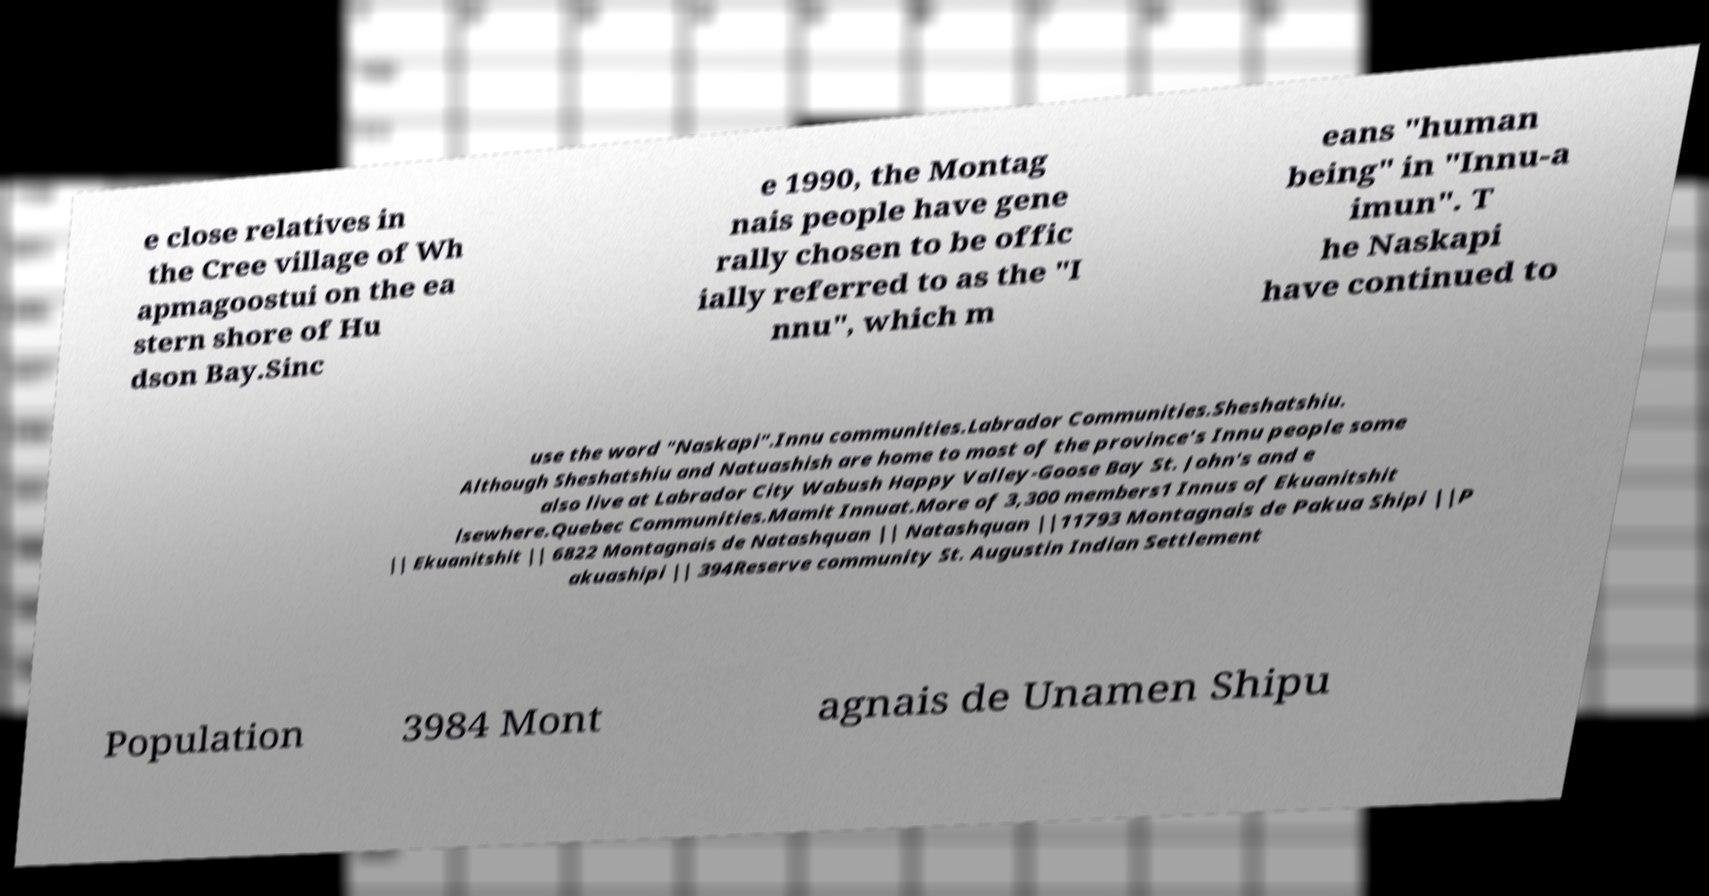Can you accurately transcribe the text from the provided image for me? e close relatives in the Cree village of Wh apmagoostui on the ea stern shore of Hu dson Bay.Sinc e 1990, the Montag nais people have gene rally chosen to be offic ially referred to as the "I nnu", which m eans "human being" in "Innu-a imun". T he Naskapi have continued to use the word "Naskapi".Innu communities.Labrador Communities.Sheshatshiu. Although Sheshatshiu and Natuashish are home to most of the province's Innu people some also live at Labrador City Wabush Happy Valley-Goose Bay St. John's and e lsewhere.Quebec Communities.Mamit Innuat.More of 3,300 members1 Innus of Ekuanitshit || Ekuanitshit || 6822 Montagnais de Natashquan || Natashquan ||11793 Montagnais de Pakua Shipi ||P akuashipi || 394Reserve community St. Augustin Indian Settlement Population 3984 Mont agnais de Unamen Shipu 